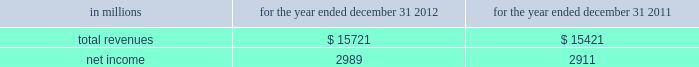See note 10 goodwill and other intangible assets for further discussion of the accounting for goodwill and other intangible assets .
The estimated amount of rbc bank ( usa ) revenue and net income ( excluding integration costs ) included in pnc 2019s consolidated income statement for 2012 was $ 1.0 billion and $ 273 million , respectively .
Upon closing and conversion of the rbc bank ( usa ) transaction , subsequent to march 2 , 2012 , separate records for rbc bank ( usa ) as a stand-alone business have not been maintained as the operations of rbc bank ( usa ) have been fully integrated into pnc .
Rbc bank ( usa ) revenue and earnings disclosed above reflect management 2019s best estimate , based on information available at the reporting date .
The table presents certain unaudited pro forma information for illustrative purposes only , for 2012 and 2011 as if rbc bank ( usa ) had been acquired on january 1 , 2011 .
The unaudited estimated pro forma information combines the historical results of rbc bank ( usa ) with the company 2019s consolidated historical results and includes certain adjustments reflecting the estimated impact of certain fair value adjustments for the respective periods .
The pro forma information is not indicative of what would have occurred had the acquisition taken place on january 1 , 2011 .
In particular , no adjustments have been made to eliminate the impact of other-than-temporary impairment losses and losses recognized on the sale of securities that may not have been necessary had the investment securities been recorded at fair value as of january 1 , 2011 .
The unaudited pro forma information does not consider any changes to the provision for credit losses resulting from recording loan assets at fair value .
Additionally , the pro forma financial information does not include the impact of possible business model changes and does not reflect pro forma adjustments to conform accounting policies between rbc bank ( usa ) and pnc .
Additionally , pnc expects to achieve further operating cost savings and other business synergies , including revenue growth , as a result of the acquisition that are not reflected in the pro forma amounts that follow .
As a result , actual results will differ from the unaudited pro forma information presented .
Table 57 : rbc bank ( usa ) and pnc unaudited pro forma results .
In connection with the rbc bank ( usa ) acquisition and other prior acquisitions , pnc recognized $ 267 million of integration charges in 2012 .
Pnc recognized $ 42 million of integration charges in 2011 in connection with prior acquisitions .
The integration charges are included in the table above .
Sale of smartstreet effective october 26 , 2012 , pnc divested certain deposits and assets of the smartstreet business unit , which was acquired by pnc as part of the rbc bank ( usa ) acquisition , to union bank , n.a .
Smartstreet is a nationwide business focused on homeowner or community association managers and had approximately $ 1 billion of assets and deposits as of september 30 , 2012 .
The gain on sale was immaterial and resulted in a reduction of goodwill and core deposit intangibles of $ 46 million and $ 13 million , respectively .
Results from operations of smartstreet from march 2 , 2012 through october 26 , 2012 are included in our consolidated income statement .
Flagstar branch acquisition effective december 9 , 2011 , pnc acquired 27 branches in the northern metropolitan atlanta , georgia area from flagstar bank , fsb , a subsidiary of flagstar bancorp , inc .
The fair value of the assets acquired totaled approximately $ 211.8 million , including $ 169.3 million in cash , $ 24.3 million in fixed assets and $ 18.2 million of goodwill and intangible assets .
We also assumed approximately $ 210.5 million of deposits associated with these branches .
No deposit premium was paid and no loans were acquired in the transaction .
Our consolidated income statement includes the impact of the branch activity subsequent to our december 9 , 2011 acquisition .
Bankatlantic branch acquisition effective june 6 , 2011 , we acquired 19 branches in the greater tampa , florida area from bankatlantic , a subsidiary of bankatlantic bancorp , inc .
The fair value of the assets acquired totaled $ 324.9 million , including $ 256.9 million in cash , $ 26.0 million in fixed assets and $ 42.0 million of goodwill and intangible assets .
We also assumed approximately $ 324.5 million of deposits associated with these branches .
A $ 39.0 million deposit premium was paid and no loans were acquired in the transaction .
Our consolidated income statement includes the impact of the branch activity subsequent to our june 6 , 2011 acquisition .
Sale of pnc global investment servicing on july 1 , 2010 , we sold pnc global investment servicing inc .
( gis ) , a leading provider of processing , technology and business intelligence services to asset managers , broker- dealers and financial advisors worldwide , for $ 2.3 billion in cash pursuant to a definitive agreement entered into on february 2 , 2010 .
This transaction resulted in a pretax gain of $ 639 million , net of transaction costs , in the third quarter of 2010 .
This gain and results of operations of gis through june 30 , 2010 are presented as income from discontinued operations , net of income taxes , on our consolidated income statement .
As part of the sale agreement , pnc has agreed to provide certain transitional services on behalf of gis until completion of related systems conversion activities .
138 the pnc financial services group , inc .
2013 form 10-k .
Excluding expenses recognized in 2012 in connection with the rbc acquisitions , what would net income be in millions? 
Computations: (2989 + 267)
Answer: 3256.0. 